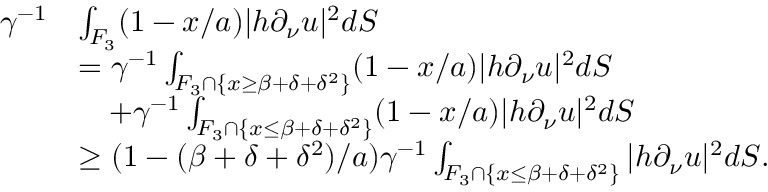Convert formula to latex. <formula><loc_0><loc_0><loc_500><loc_500>\begin{array} { r l } { \gamma ^ { - 1 } } & { \int _ { F _ { 3 } } ( 1 - x / a ) | h \partial _ { \nu } u | ^ { 2 } d S } \\ & { = \gamma ^ { - 1 } \int _ { F _ { 3 } \cap \{ x \geq \beta + \delta + \delta ^ { 2 } \} } ( 1 - x / a ) | h \partial _ { \nu } u | ^ { 2 } d S } \\ & { \quad + \gamma ^ { - 1 } \int _ { F _ { 3 } \cap \{ x \leq \beta + \delta + \delta ^ { 2 } \} } ( 1 - x / a ) | h \partial _ { \nu } u | ^ { 2 } d S } \\ & { \geq ( 1 - ( \beta + \delta + \delta ^ { 2 } ) / a ) \gamma ^ { - 1 } \int _ { F _ { 3 } \cap \{ x \leq \beta + \delta + \delta ^ { 2 } \} } | h \partial _ { \nu } u | ^ { 2 } d S . } \end{array}</formula> 